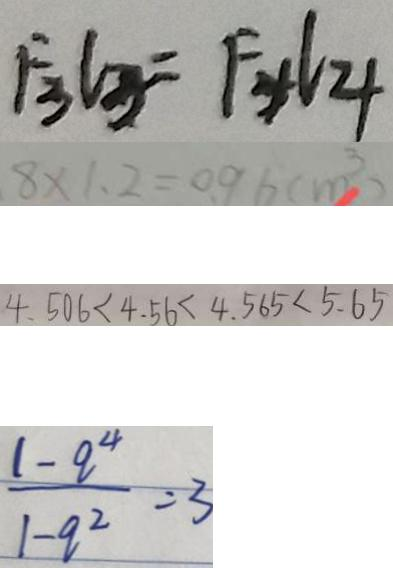<formula> <loc_0><loc_0><loc_500><loc_500>F _ { 3 } l _ { 3 } = F _ { 4 } l _ { 4 } 
 8 \times 1 . 2 = 0 . 9 6 ( m ^ { 3 } ) 
 4 . 5 0 6 < 4 . 5 6 < 4 . 5 6 5 < 5 . 6 5 
 \frac { 1 - q ^ { 4 } } { 1 - q ^ { 2 } } = 3</formula> 